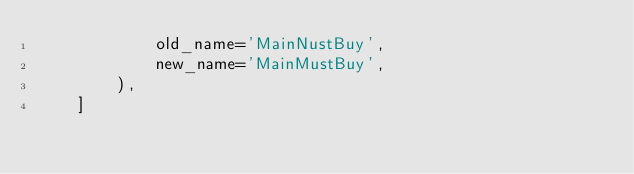<code> <loc_0><loc_0><loc_500><loc_500><_Python_>            old_name='MainNustBuy',
            new_name='MainMustBuy',
        ),
    ]
</code> 